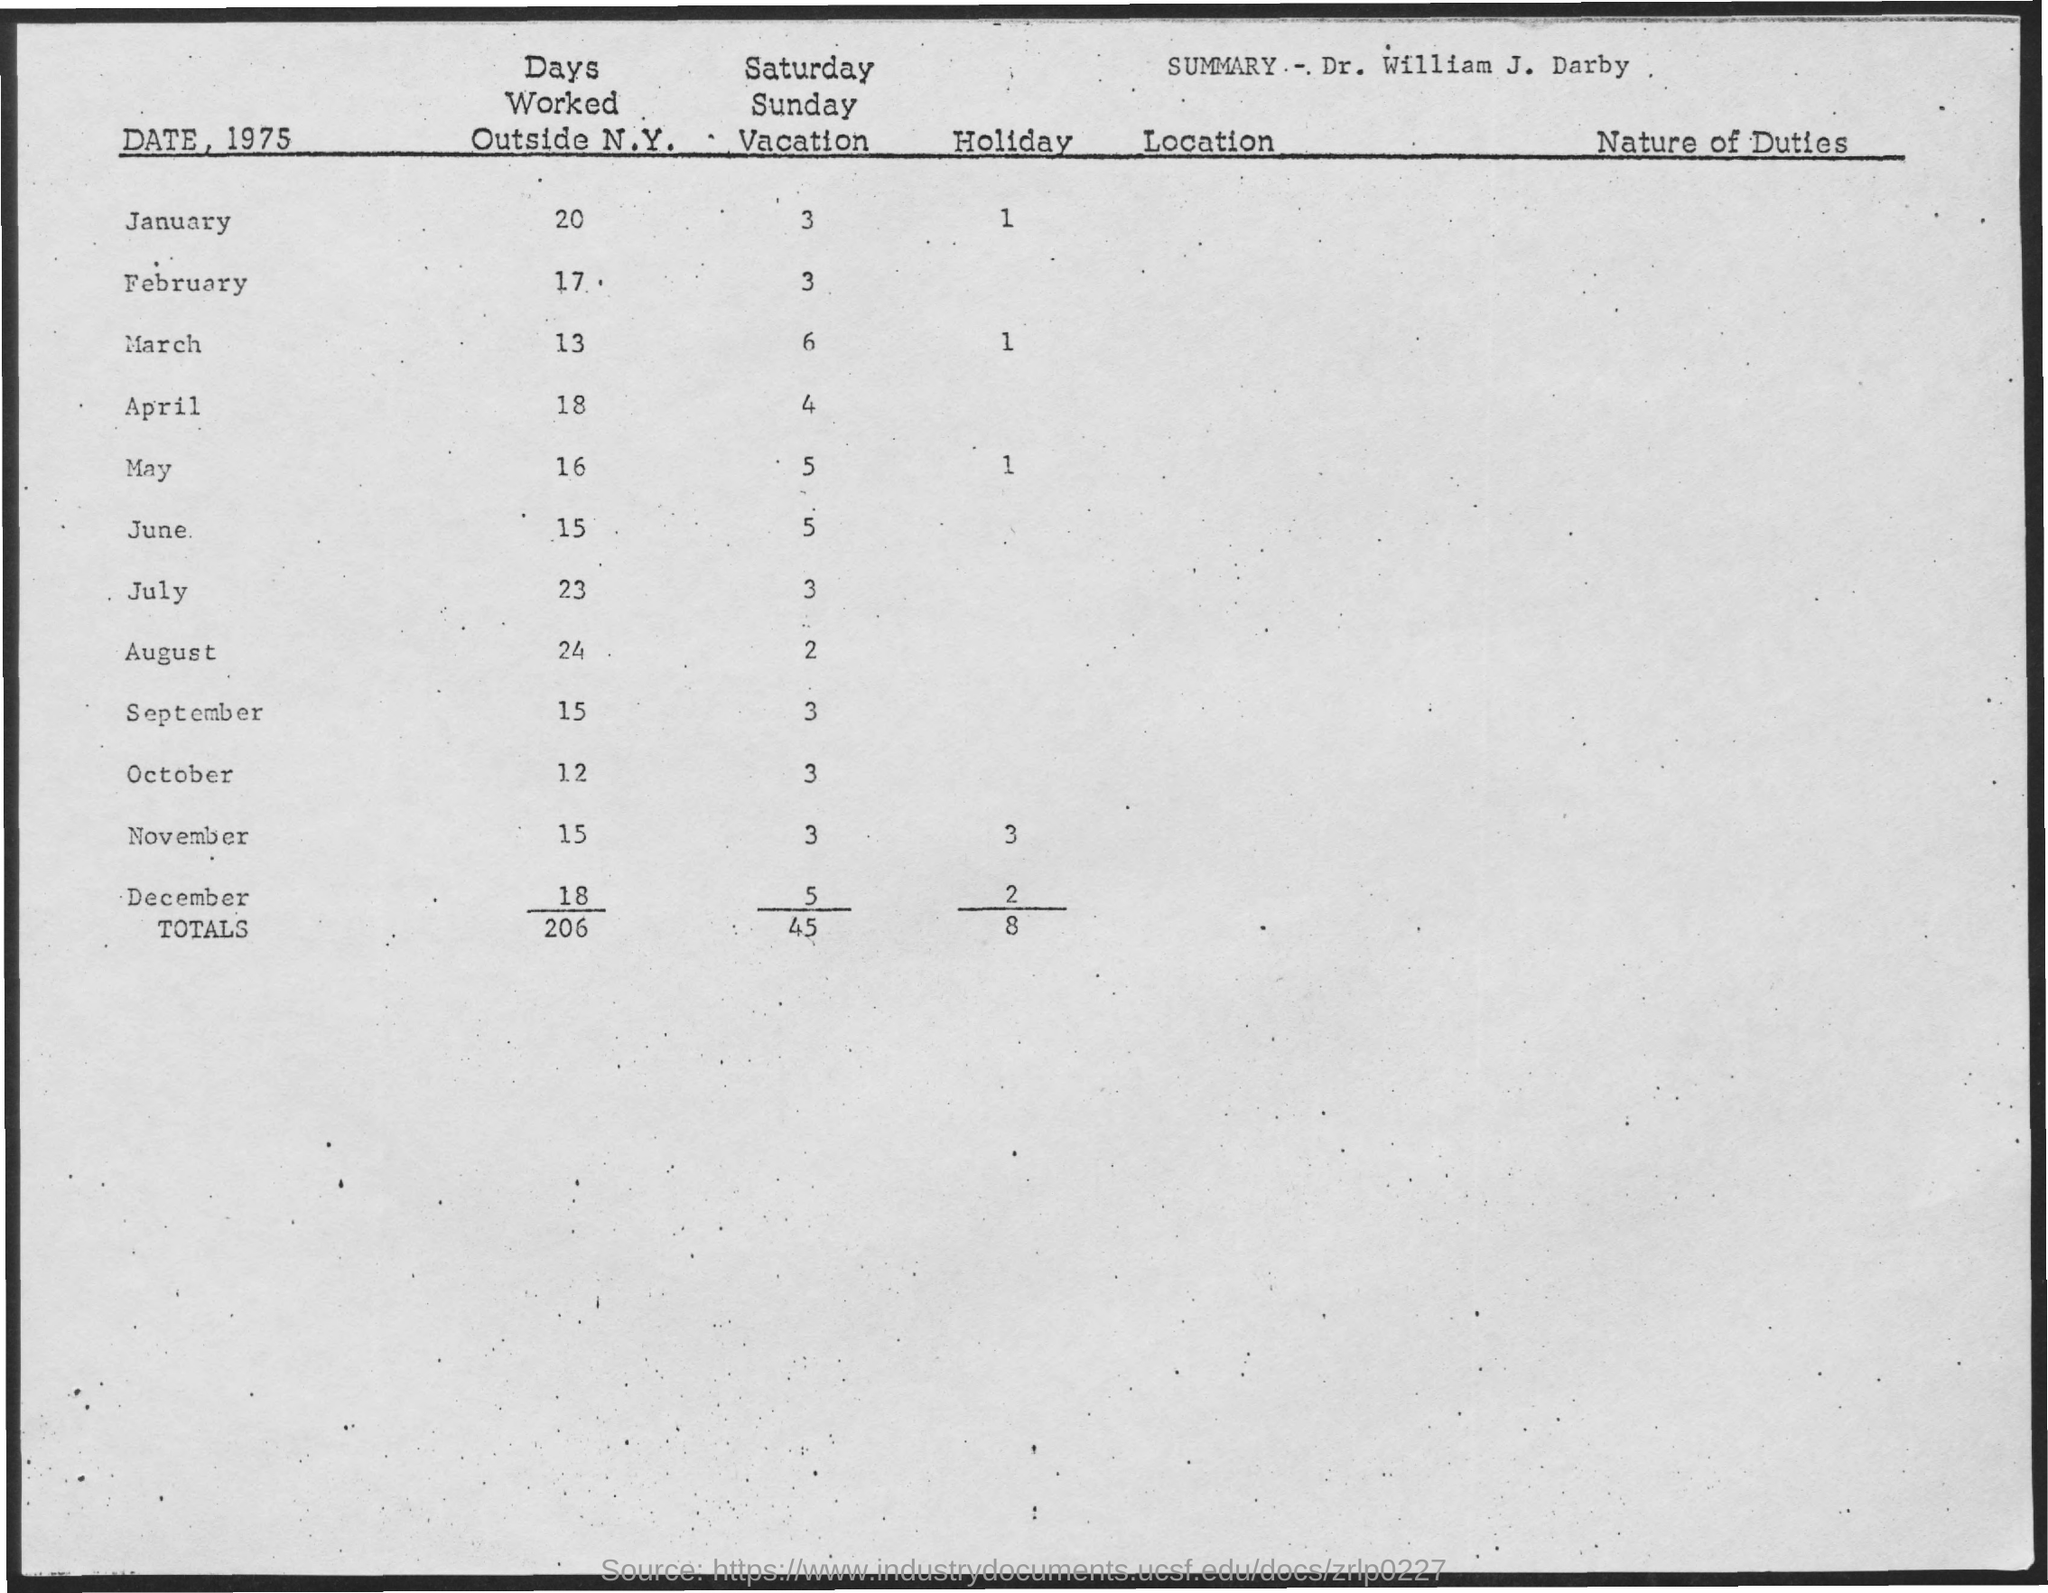What is the total number of days worked outside N.Y.?
Your response must be concise. 206. What is the total number of Holidays?
Offer a very short reply. 8. What is the total Saturday-Sunday vacations?
Make the answer very short. 45. What is the number of days worked outside N.Y. in October?
Provide a succinct answer. 12. What is the number of days worked outside N.Y. in January?
Provide a short and direct response. 20. What is the number of holidays in January?
Offer a very short reply. 1. What is the number of Saturday-Sunday in January?
Keep it short and to the point. 3. 